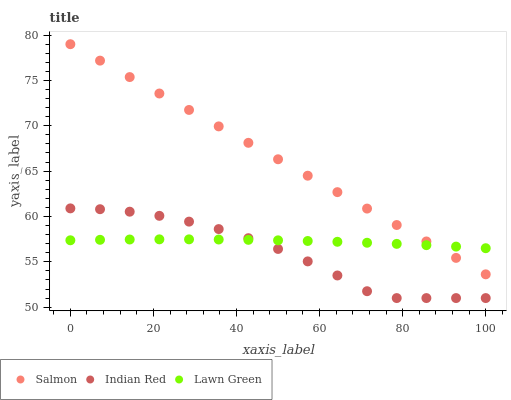Does Indian Red have the minimum area under the curve?
Answer yes or no. Yes. Does Salmon have the maximum area under the curve?
Answer yes or no. Yes. Does Salmon have the minimum area under the curve?
Answer yes or no. No. Does Indian Red have the maximum area under the curve?
Answer yes or no. No. Is Salmon the smoothest?
Answer yes or no. Yes. Is Indian Red the roughest?
Answer yes or no. Yes. Is Indian Red the smoothest?
Answer yes or no. No. Is Salmon the roughest?
Answer yes or no. No. Does Indian Red have the lowest value?
Answer yes or no. Yes. Does Salmon have the lowest value?
Answer yes or no. No. Does Salmon have the highest value?
Answer yes or no. Yes. Does Indian Red have the highest value?
Answer yes or no. No. Is Indian Red less than Salmon?
Answer yes or no. Yes. Is Salmon greater than Indian Red?
Answer yes or no. Yes. Does Salmon intersect Lawn Green?
Answer yes or no. Yes. Is Salmon less than Lawn Green?
Answer yes or no. No. Is Salmon greater than Lawn Green?
Answer yes or no. No. Does Indian Red intersect Salmon?
Answer yes or no. No. 